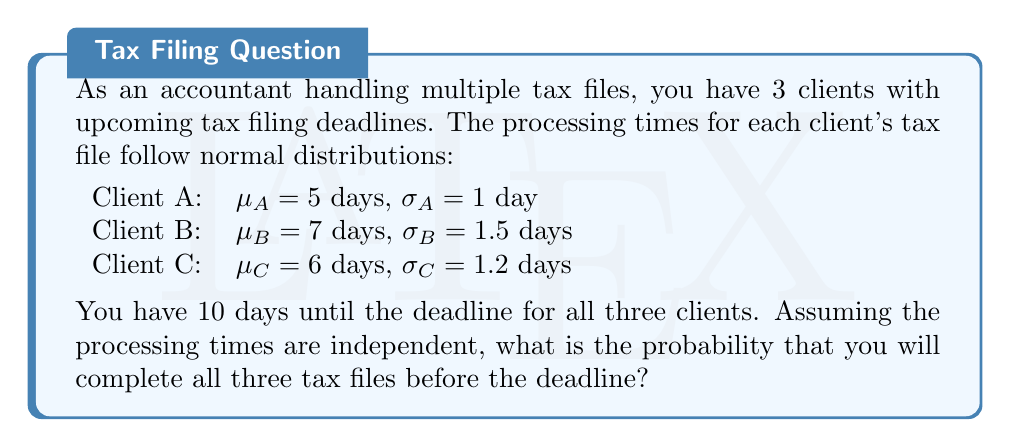Teach me how to tackle this problem. To solve this problem, we need to follow these steps:

1) First, we need to calculate the probability of completing each client's tax file within 10 days.

2) For each client, we can use the normal distribution and calculate the z-score for 10 days:

   $z = \frac{x - \mu}{\sigma}$

   where $x$ is 10 days (the deadline), $\mu$ is the mean processing time, and $\sigma$ is the standard deviation.

3) Then, we can use a standard normal distribution table or calculator to find the probability of completing each file within 10 days.

4) Since the events are independent, we multiply the individual probabilities to get the probability of completing all three files within 10 days.

Let's calculate for each client:

For Client A:
$z_A = \frac{10 - 5}{1} = 5$
$P(A) = P(Z < 5) \approx 0.9999997$

For Client B:
$z_B = \frac{10 - 7}{1.5} = 2$
$P(B) = P(Z < 2) \approx 0.9772499$

For Client C:
$z_C = \frac{10 - 6}{1.2} = 3.3333$
$P(C) = P(Z < 3.3333) \approx 0.9995738$

Now, the probability of completing all three files before the deadline is:

$P(\text{All}) = P(A) \times P(B) \times P(C)$

$P(\text{All}) = 0.9999997 \times 0.9772499 \times 0.9995738$

$P(\text{All}) \approx 0.9768$
Answer: The probability of completing all three tax files before the 10-day deadline is approximately 0.9768 or 97.68%. 